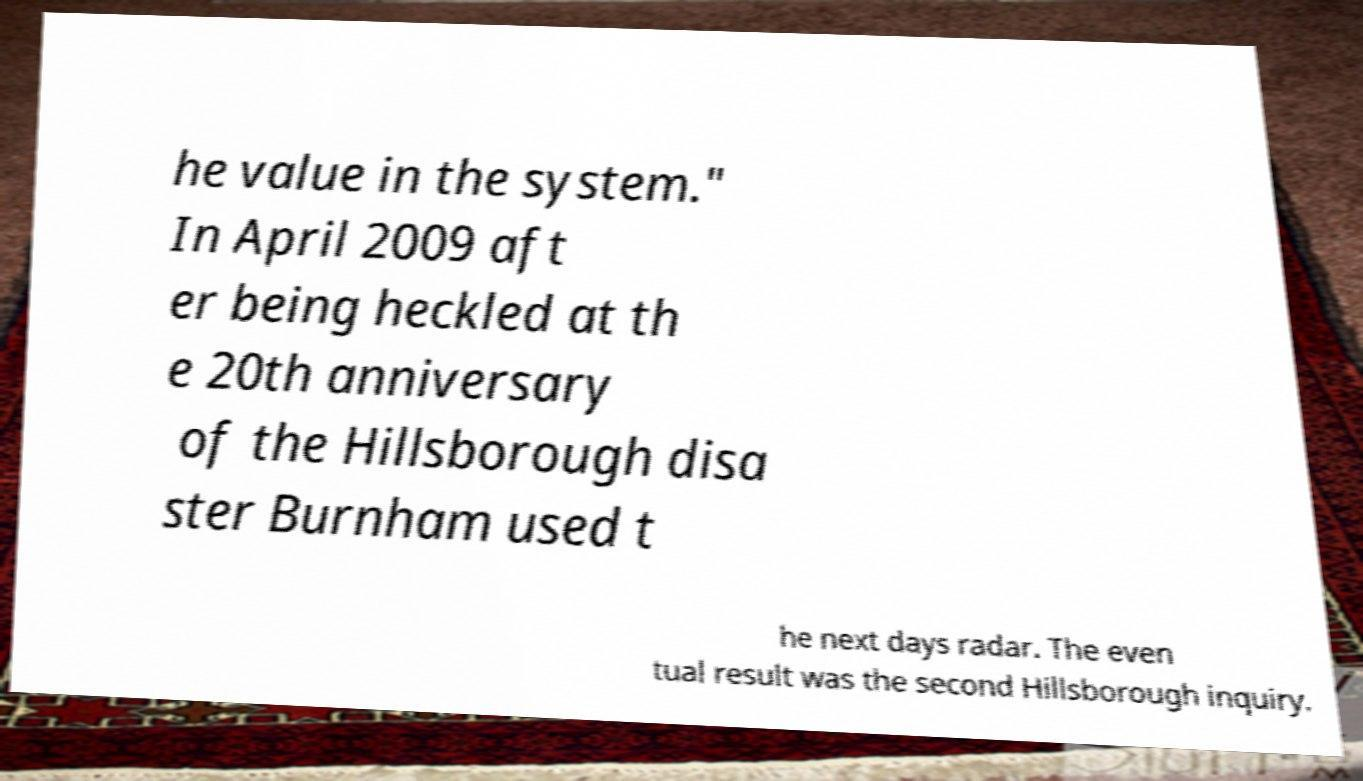Can you read and provide the text displayed in the image?This photo seems to have some interesting text. Can you extract and type it out for me? he value in the system." In April 2009 aft er being heckled at th e 20th anniversary of the Hillsborough disa ster Burnham used t he next days radar. The even tual result was the second Hillsborough inquiry. 